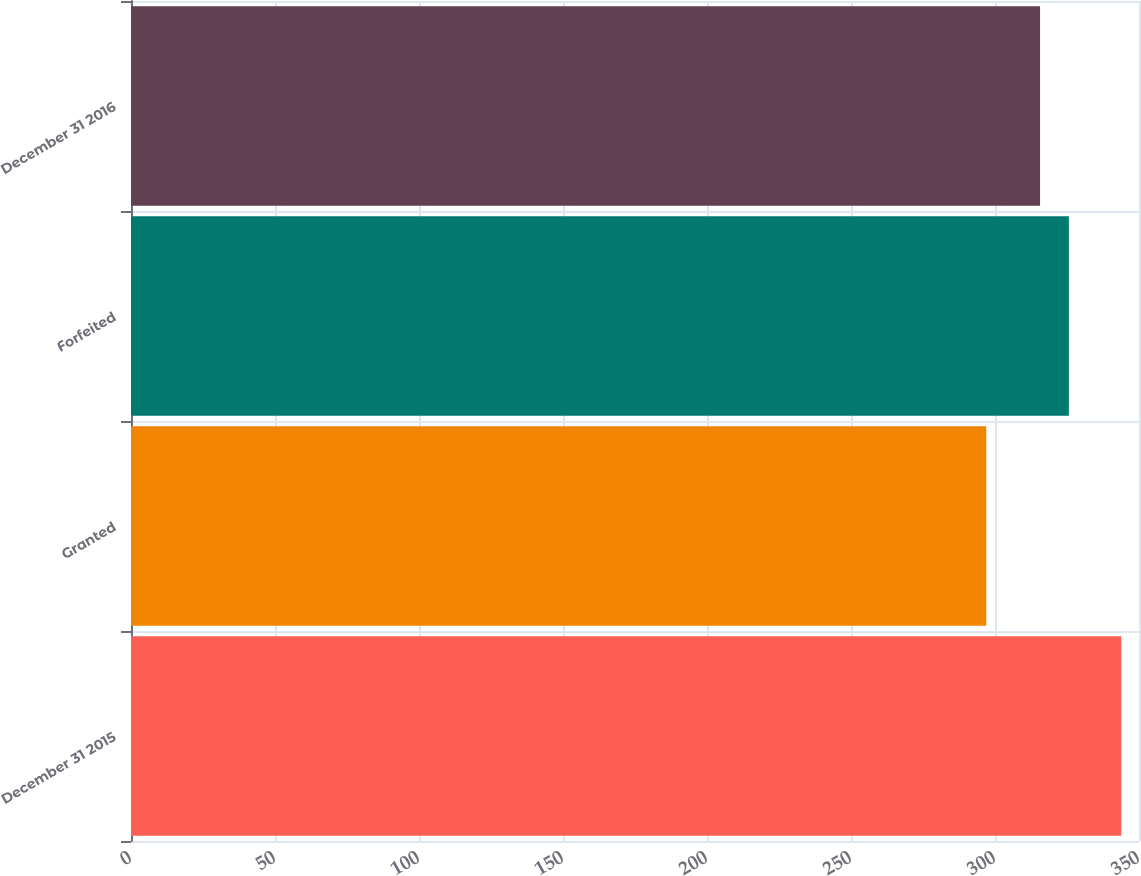<chart> <loc_0><loc_0><loc_500><loc_500><bar_chart><fcel>December 31 2015<fcel>Granted<fcel>Forfeited<fcel>December 31 2016<nl><fcel>343.86<fcel>296.97<fcel>325.65<fcel>315.65<nl></chart> 